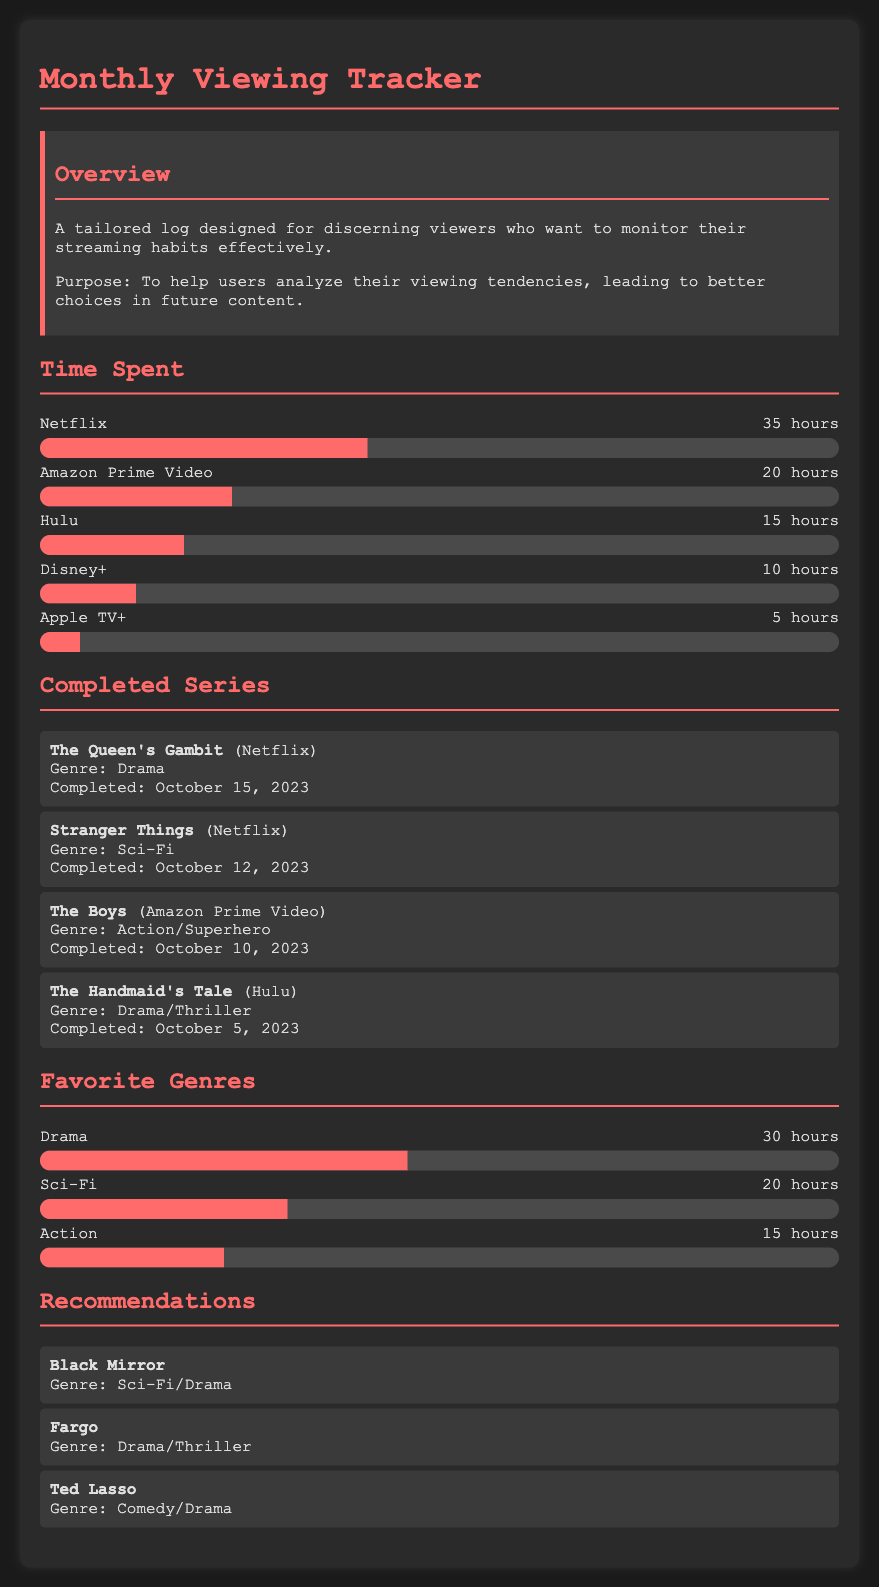What is the total time spent on Netflix? The total time spent on Netflix is explicitly listed in the document as 35 hours.
Answer: 35 hours How many completed series are listed in the document? The document includes a section that lists four completed series, detailed in the completed series section.
Answer: 4 What is the genre of "The Boys"? The genre of "The Boys" is provided in the completed series section, which states it is Action/Superhero.
Answer: Action/Superhero Which streaming service had the least amount of time spent? The document specifies the time spent on each service, with Apple TV+ having the least at 5 hours.
Answer: Apple TV+ What is the favorite genre with the highest viewing time? The favorite genre with the highest viewing time can be determined from the favorite genres section, where Drama is listed at 30 hours.
Answer: Drama How many hours were spent on Hulu? The document clearly shows that 15 hours were spent on Hulu in the time spent section.
Answer: 15 hours What recommendations are listed? The recommendations section offers three titles, which are listed together without specific numbers or details, but are provided sequentially as "Black Mirror", "Fargo", and "Ted Lasso."
Answer: Black Mirror, Fargo, Ted Lasso Which genre accounted for the most viewing time after Drama? Based on the favorite genres section, Sci-Fi follows Drama in total hours viewed, with 20 hours.
Answer: Sci-Fi When was "The Handmaid's Tale" completed? The completed series section states that "The Handmaid's Tale" was completed on October 5, 2023.
Answer: October 5, 2023 